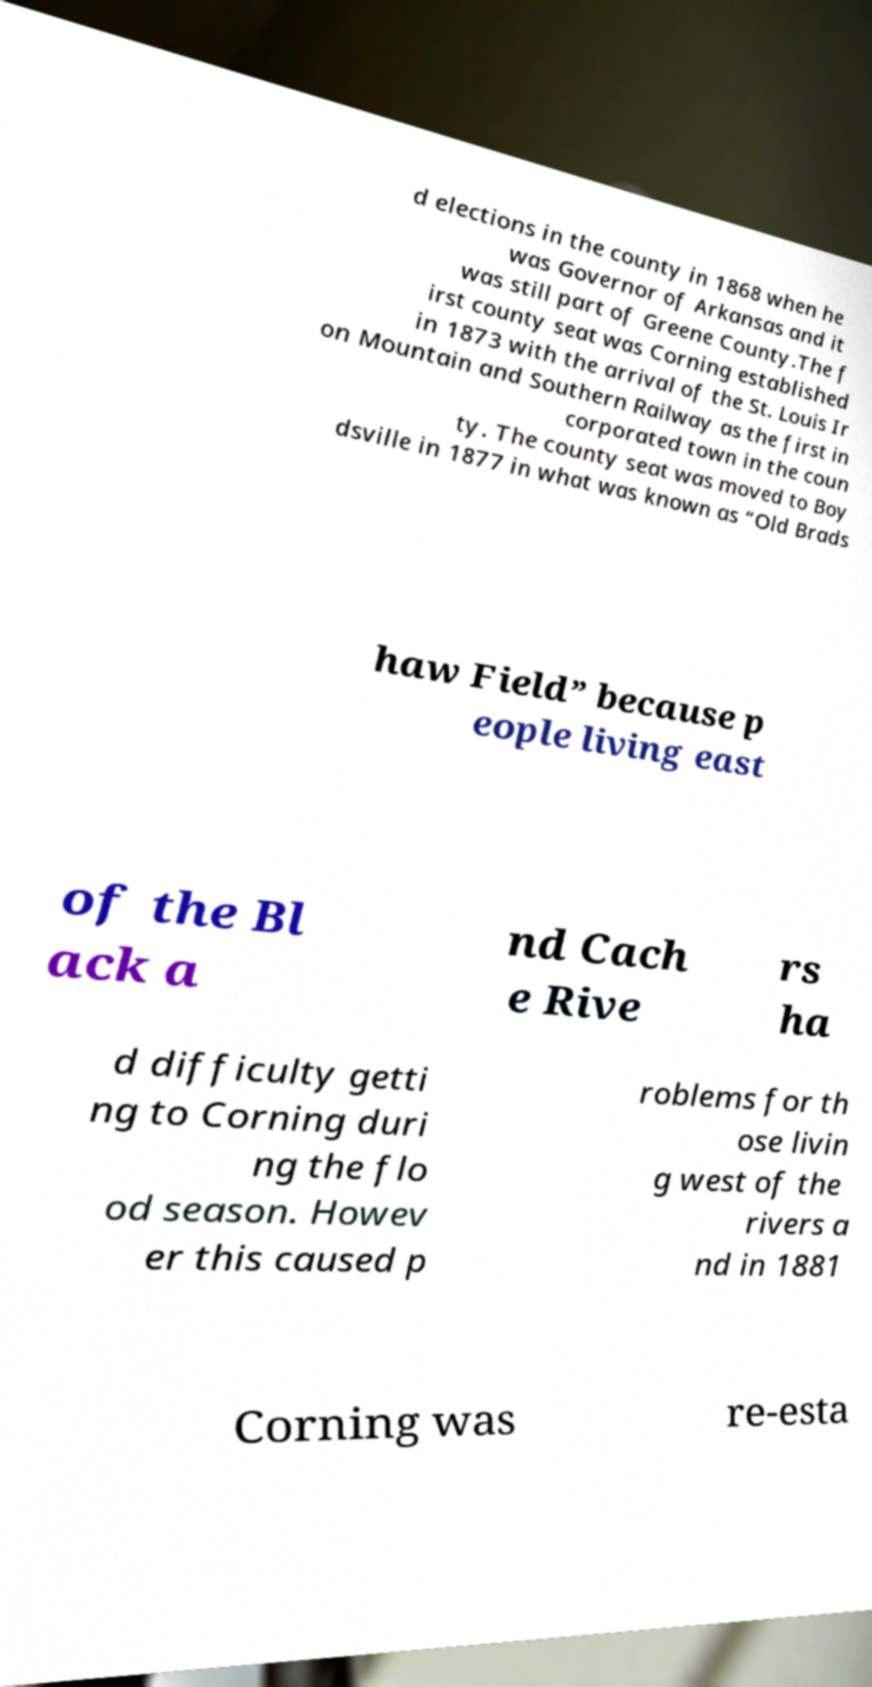For documentation purposes, I need the text within this image transcribed. Could you provide that? d elections in the county in 1868 when he was Governor of Arkansas and it was still part of Greene County.The f irst county seat was Corning established in 1873 with the arrival of the St. Louis Ir on Mountain and Southern Railway as the first in corporated town in the coun ty. The county seat was moved to Boy dsville in 1877 in what was known as “Old Brads haw Field” because p eople living east of the Bl ack a nd Cach e Rive rs ha d difficulty getti ng to Corning duri ng the flo od season. Howev er this caused p roblems for th ose livin g west of the rivers a nd in 1881 Corning was re-esta 